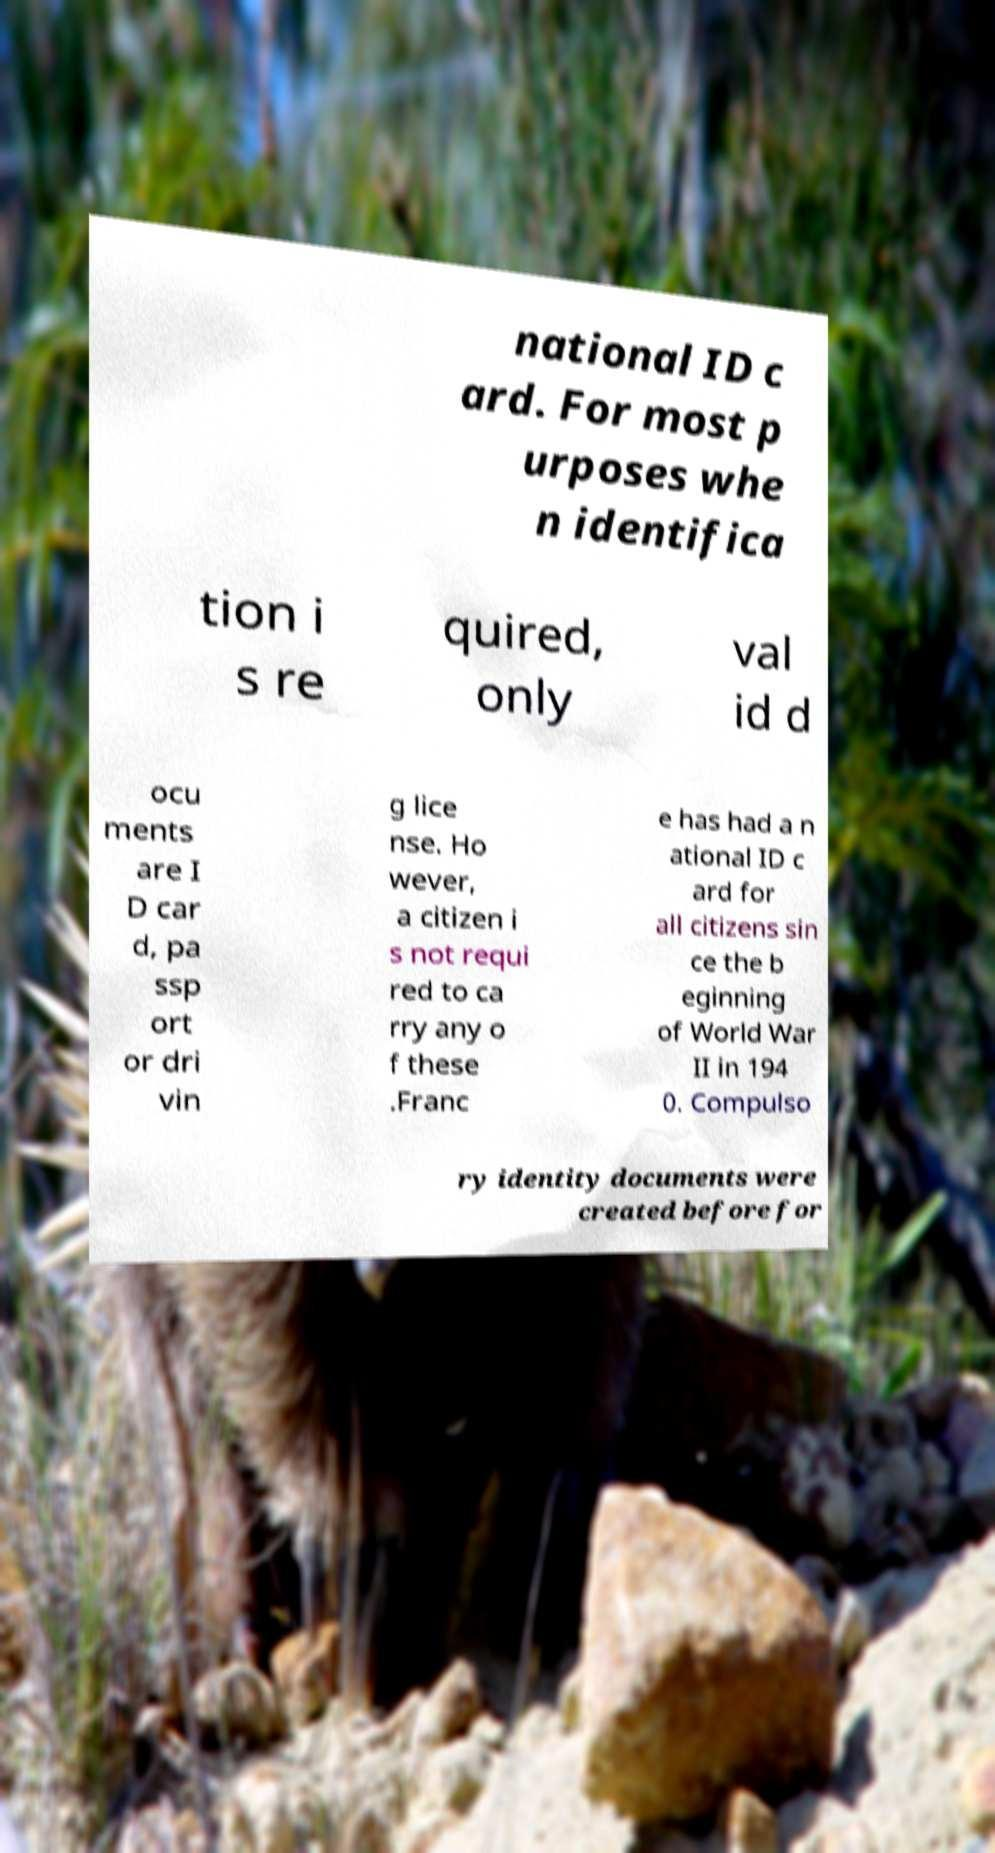For documentation purposes, I need the text within this image transcribed. Could you provide that? national ID c ard. For most p urposes whe n identifica tion i s re quired, only val id d ocu ments are I D car d, pa ssp ort or dri vin g lice nse. Ho wever, a citizen i s not requi red to ca rry any o f these .Franc e has had a n ational ID c ard for all citizens sin ce the b eginning of World War II in 194 0. Compulso ry identity documents were created before for 